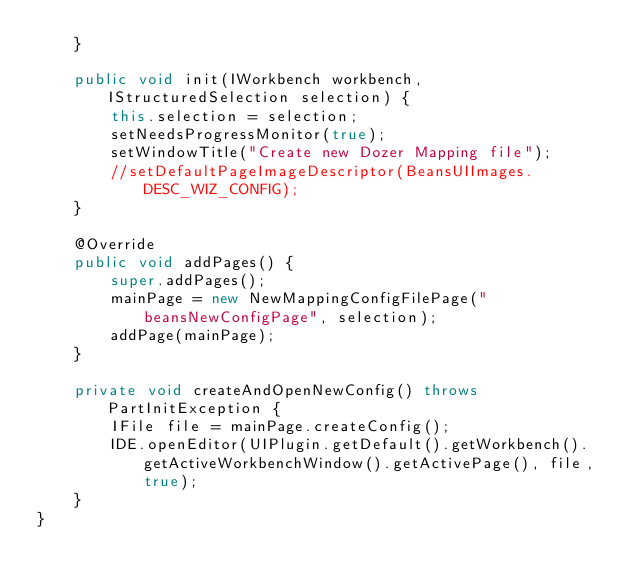Convert code to text. <code><loc_0><loc_0><loc_500><loc_500><_Java_>	}

	public void init(IWorkbench workbench, IStructuredSelection selection) {
		this.selection = selection;
		setNeedsProgressMonitor(true);
		setWindowTitle("Create new Dozer Mapping file");
		//setDefaultPageImageDescriptor(BeansUIImages.DESC_WIZ_CONFIG);		
	}

	@Override
	public void addPages() {
		super.addPages();
		mainPage = new NewMappingConfigFilePage("beansNewConfigPage", selection);
		addPage(mainPage);
	}
	
	private void createAndOpenNewConfig() throws PartInitException {
		IFile file = mainPage.createConfig();
		IDE.openEditor(UIPlugin.getDefault().getWorkbench().getActiveWorkbenchWindow().getActivePage(), file, true);
	}	
}
</code> 